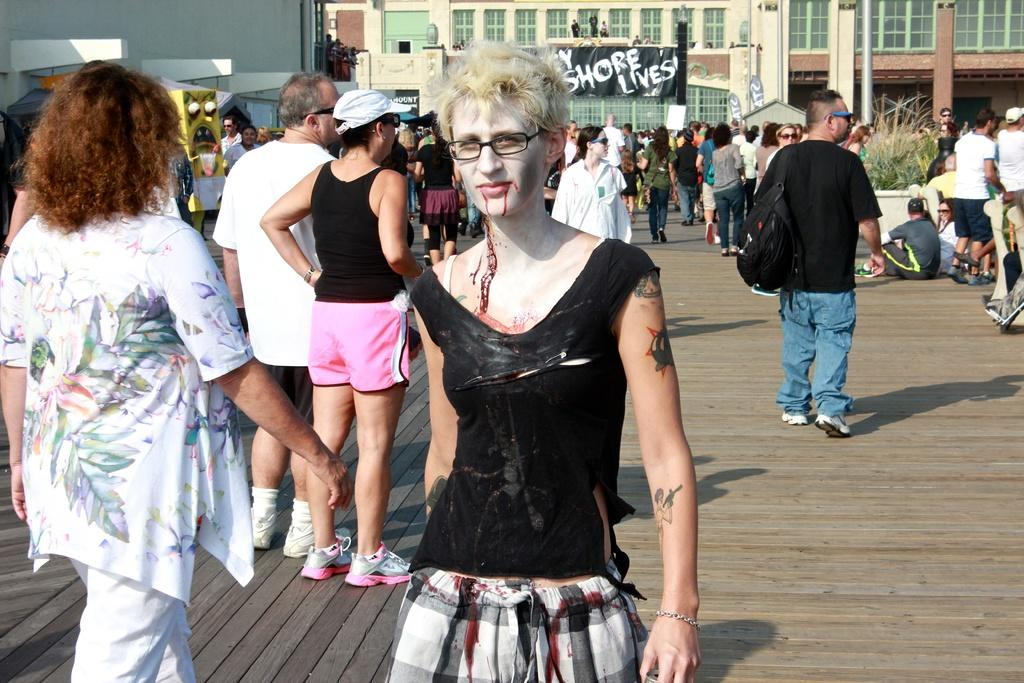What is happening with the people in the image? There are people on the ground in the image. What can be seen in the background of the image? There is a building with a banner in the background. What is the color of the object in the image? There is a yellow object in the image. What type of plant is present in the image? There is a potted plant in the image. What is the purpose of the iron pole between the people in the image? There is an iron pole between the people in the image. What type of drain is visible in the image? There is no drain present in the image. What is the purpose of the mitten in the image? There is no mitten present in the image. 